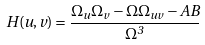<formula> <loc_0><loc_0><loc_500><loc_500>H ( u , v ) = \frac { \Omega _ { u } \Omega _ { v } - \Omega \Omega _ { u v } - A B } { \Omega ^ { 3 } }</formula> 